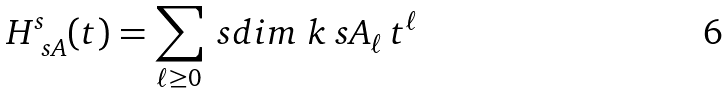Convert formula to latex. <formula><loc_0><loc_0><loc_500><loc_500>H ^ { s } _ { \ s A } ( t ) = \sum _ { \ell \geq 0 } \ s d i m _ { \ } k \ s A _ { \ell } \, t ^ { \ell }</formula> 